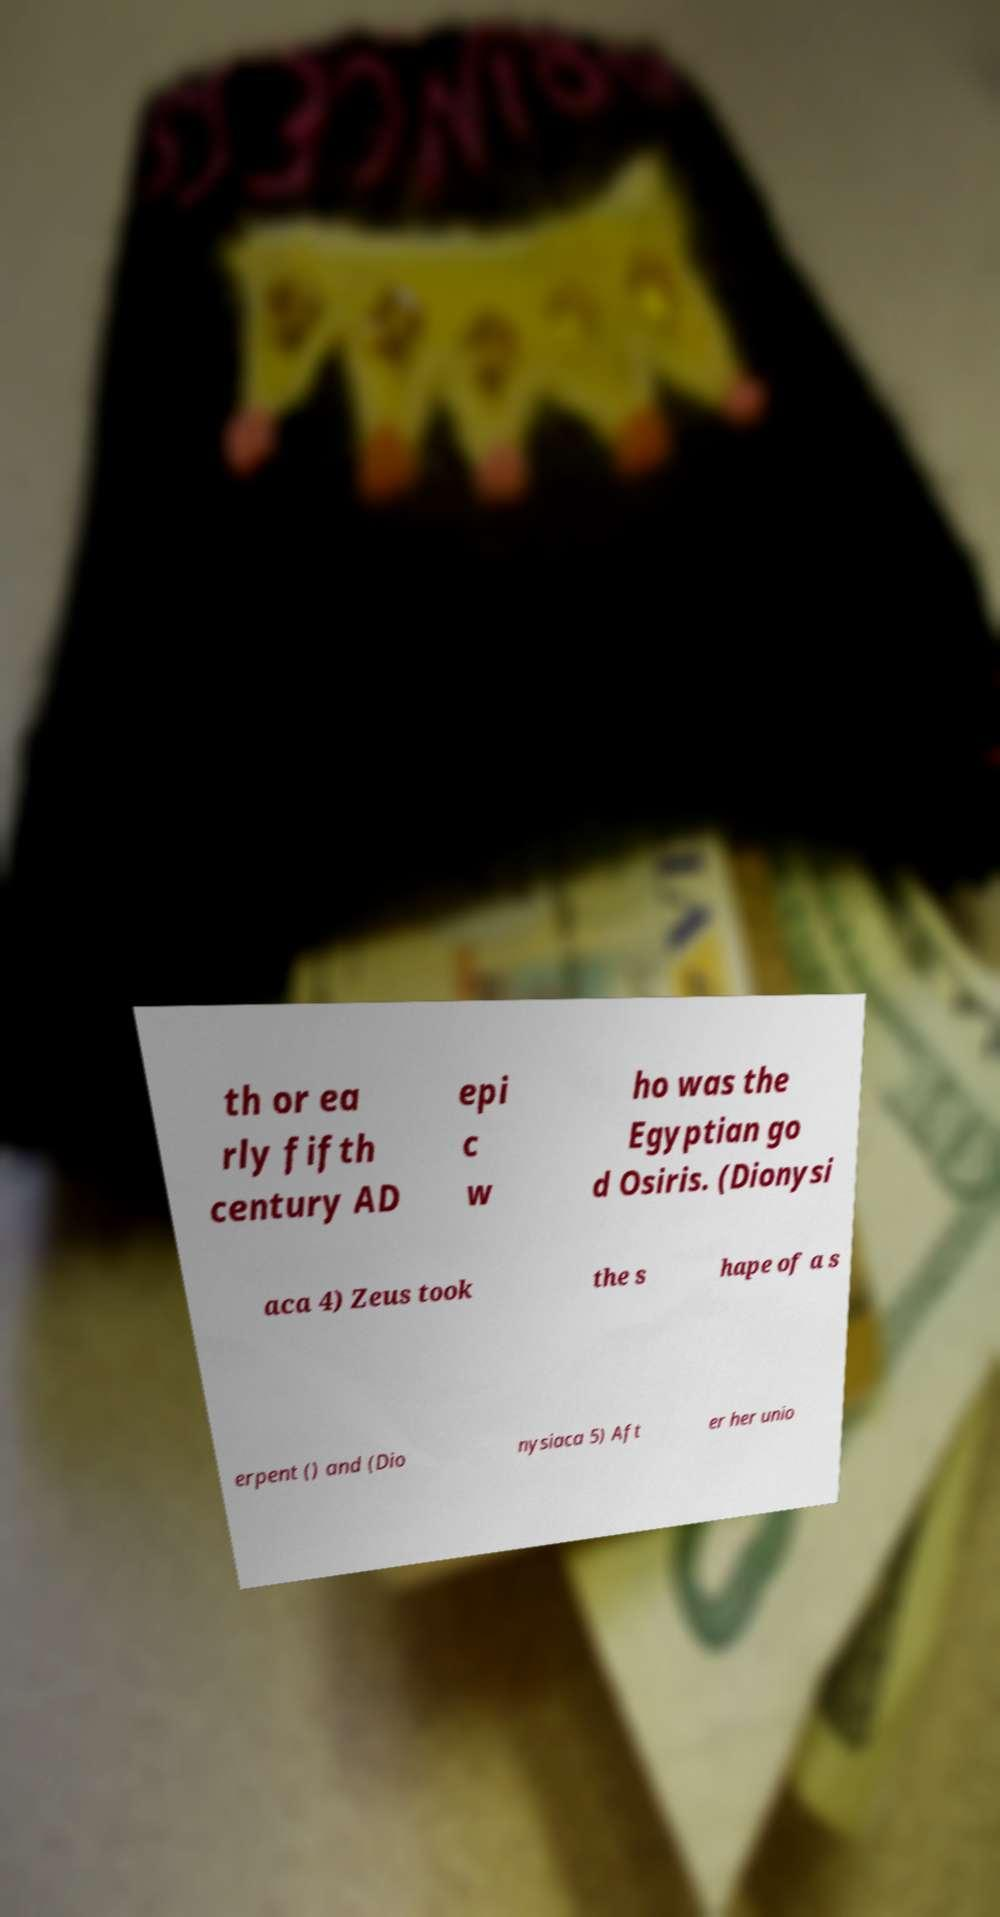Can you read and provide the text displayed in the image?This photo seems to have some interesting text. Can you extract and type it out for me? th or ea rly fifth century AD epi c w ho was the Egyptian go d Osiris. (Dionysi aca 4) Zeus took the s hape of a s erpent () and (Dio nysiaca 5) Aft er her unio 